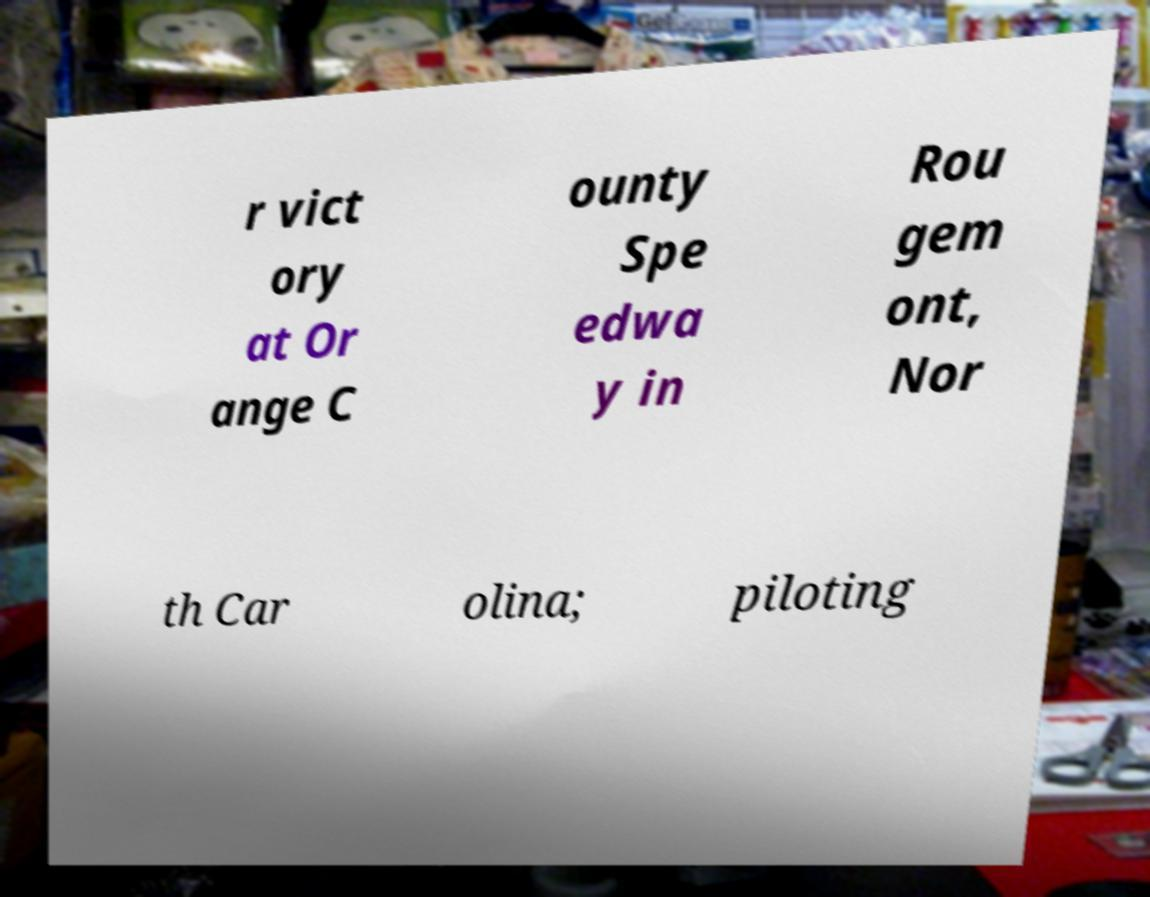Please read and relay the text visible in this image. What does it say? r vict ory at Or ange C ounty Spe edwa y in Rou gem ont, Nor th Car olina; piloting 